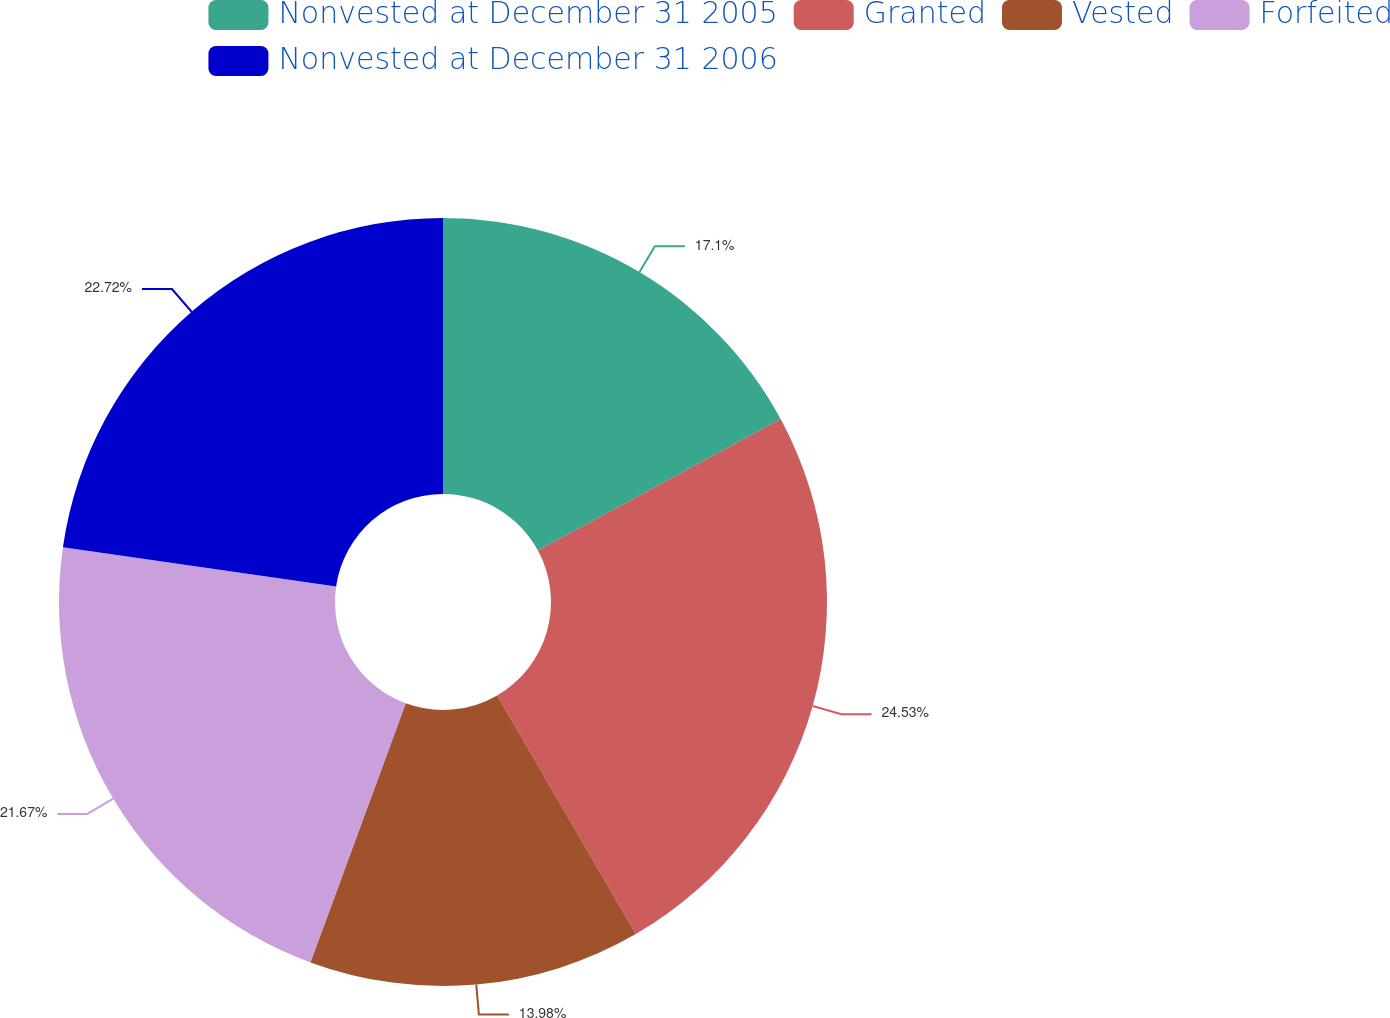Convert chart. <chart><loc_0><loc_0><loc_500><loc_500><pie_chart><fcel>Nonvested at December 31 2005<fcel>Granted<fcel>Vested<fcel>Forfeited<fcel>Nonvested at December 31 2006<nl><fcel>17.1%<fcel>24.53%<fcel>13.98%<fcel>21.67%<fcel>22.72%<nl></chart> 